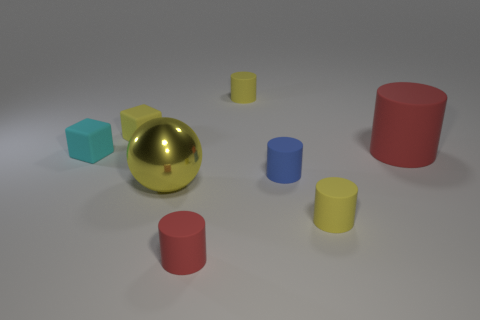What is the size of the yellow matte thing that is on the left side of the large object on the left side of the tiny yellow matte object that is behind the yellow block?
Your answer should be compact. Small. How many other objects are there of the same shape as the cyan thing?
Your answer should be very brief. 1. There is a tiny matte cylinder that is to the right of the tiny blue thing; is it the same color as the big object right of the yellow shiny object?
Offer a very short reply. No. There is another rubber block that is the same size as the cyan cube; what is its color?
Your answer should be compact. Yellow. Are there any other cylinders that have the same color as the large matte cylinder?
Give a very brief answer. Yes. Is the size of the cube in front of the yellow cube the same as the large red cylinder?
Provide a succinct answer. No. Is the number of blue things that are behind the small cyan matte cube the same as the number of tiny cyan rubber objects?
Offer a terse response. No. How many objects are either small rubber things behind the small cyan rubber block or yellow shiny balls?
Make the answer very short. 3. There is a yellow object that is to the left of the small red matte thing and right of the yellow matte cube; what shape is it?
Provide a short and direct response. Sphere. What number of things are either red rubber cylinders left of the large cylinder or matte cylinders that are behind the blue cylinder?
Provide a short and direct response. 3. 